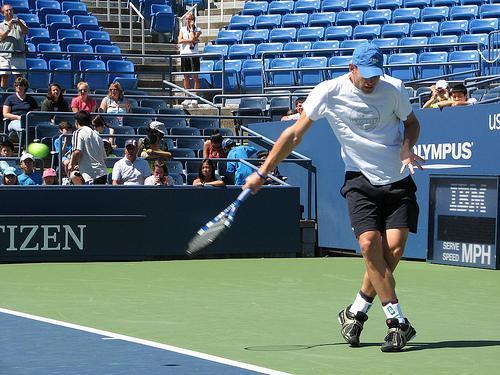How many people are holding rackets?
Give a very brief answer. 1. 